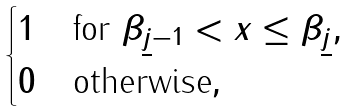Convert formula to latex. <formula><loc_0><loc_0><loc_500><loc_500>\begin{cases} 1 & \text {for $\beta_{\underline{j}-1}<x\leq \beta_{\underline{j} }$} , \\ 0 & \text {otherwise} , \end{cases}</formula> 